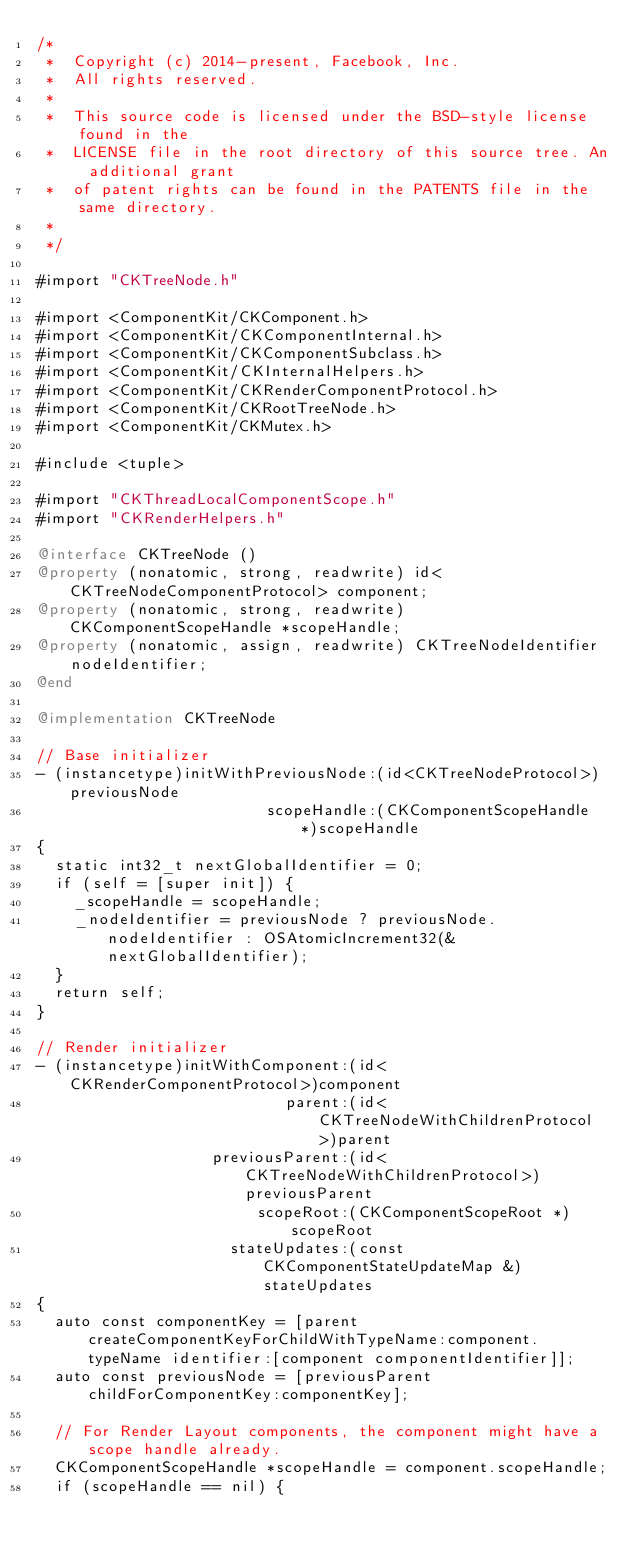Convert code to text. <code><loc_0><loc_0><loc_500><loc_500><_ObjectiveC_>/*
 *  Copyright (c) 2014-present, Facebook, Inc.
 *  All rights reserved.
 *
 *  This source code is licensed under the BSD-style license found in the
 *  LICENSE file in the root directory of this source tree. An additional grant
 *  of patent rights can be found in the PATENTS file in the same directory.
 *
 */

#import "CKTreeNode.h"

#import <ComponentKit/CKComponent.h>
#import <ComponentKit/CKComponentInternal.h>
#import <ComponentKit/CKComponentSubclass.h>
#import <ComponentKit/CKInternalHelpers.h>
#import <ComponentKit/CKRenderComponentProtocol.h>
#import <ComponentKit/CKRootTreeNode.h>
#import <ComponentKit/CKMutex.h>

#include <tuple>

#import "CKThreadLocalComponentScope.h"
#import "CKRenderHelpers.h"

@interface CKTreeNode ()
@property (nonatomic, strong, readwrite) id<CKTreeNodeComponentProtocol> component;
@property (nonatomic, strong, readwrite) CKComponentScopeHandle *scopeHandle;
@property (nonatomic, assign, readwrite) CKTreeNodeIdentifier nodeIdentifier;
@end

@implementation CKTreeNode

// Base initializer
- (instancetype)initWithPreviousNode:(id<CKTreeNodeProtocol>)previousNode
                         scopeHandle:(CKComponentScopeHandle *)scopeHandle
{
  static int32_t nextGlobalIdentifier = 0;
  if (self = [super init]) {
    _scopeHandle = scopeHandle;
    _nodeIdentifier = previousNode ? previousNode.nodeIdentifier : OSAtomicIncrement32(&nextGlobalIdentifier);
  }
  return self;
}

// Render initializer
- (instancetype)initWithComponent:(id<CKRenderComponentProtocol>)component
                           parent:(id<CKTreeNodeWithChildrenProtocol>)parent
                   previousParent:(id<CKTreeNodeWithChildrenProtocol>)previousParent
                        scopeRoot:(CKComponentScopeRoot *)scopeRoot
                     stateUpdates:(const CKComponentStateUpdateMap &)stateUpdates
{
  auto const componentKey = [parent createComponentKeyForChildWithTypeName:component.typeName identifier:[component componentIdentifier]];
  auto const previousNode = [previousParent childForComponentKey:componentKey];

  // For Render Layout components, the component might have a scope handle already.
  CKComponentScopeHandle *scopeHandle = component.scopeHandle;
  if (scopeHandle == nil) {</code> 